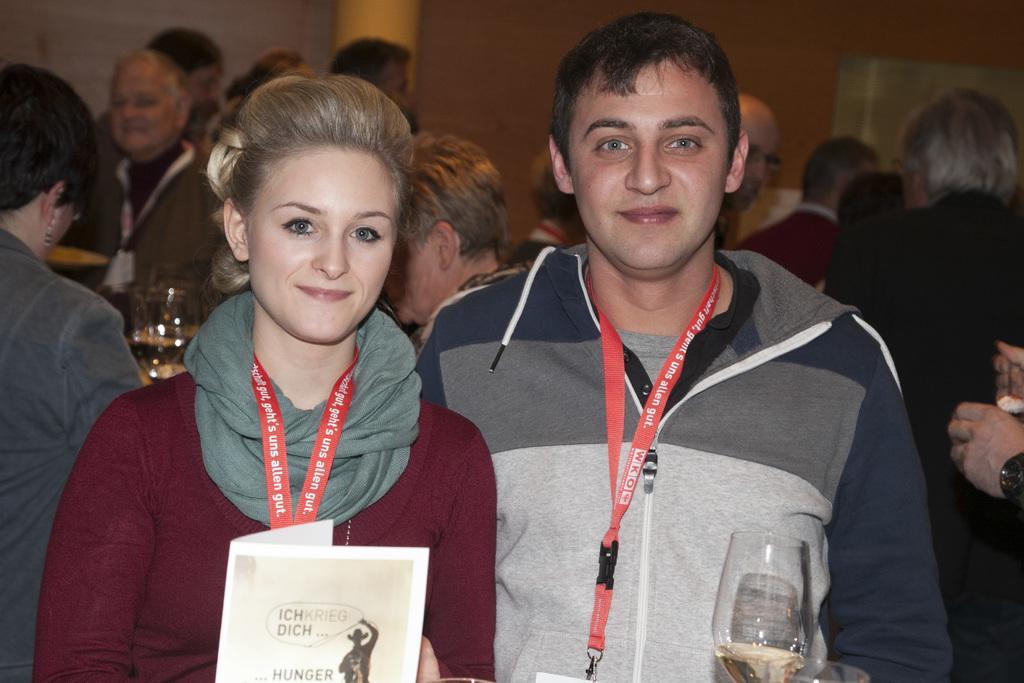In one or two sentences, can you explain what this image depicts? In this image I can see number of people. In front I can see a woman and a man with smile on their faces. I can see man is holding a glass and woman is holding a paper. I can also see ID card on their neck. 